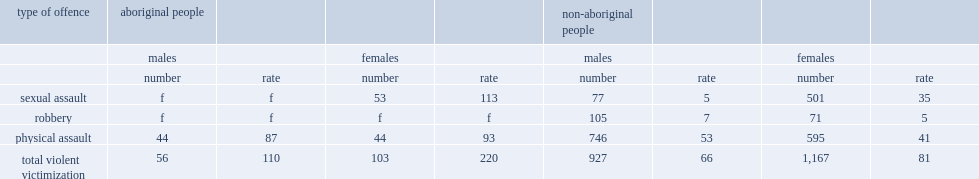How many times did aboriginal females (220e incidents per 1,000 people) have an overall rate of violent victimization higher than that of aboriginal males? 2. How many times did aboriginal females (220e incidents per 1,000 people) have an overall rate of violent victimization higher than that of non-aboriginal males? 2.716049. How many times did aboriginal females (220e incidents per 1,000 people) have an overall rate of violent victimization higher than that of non-aboriginal males? 3.333333. 